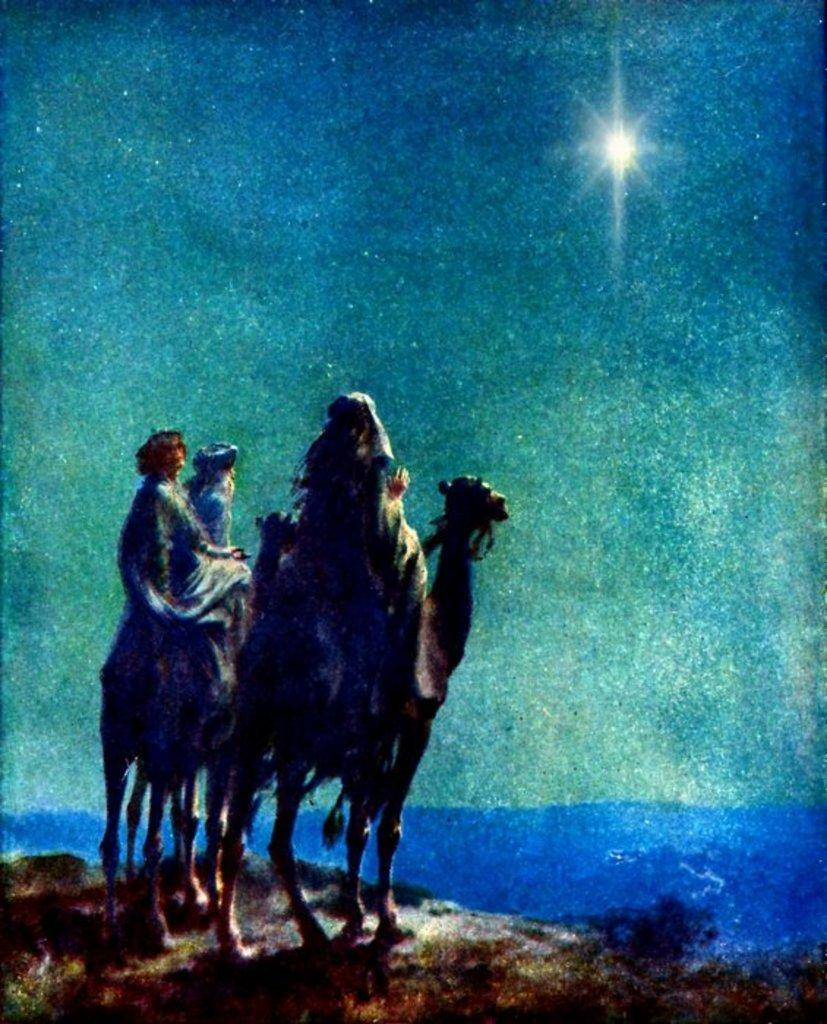What is the main subject of the painting in the image? The painting contains camels. Are there any other elements present in the painting besides the camels? Yes, the painting contains a group of people. What type of fuel is being used by the dogs in the painting? There are no dogs present in the painting; it features camels and a group of people. What type of writing can be seen on the painting? There is no writing present on the painting; it only contains images of camels and a group of people. 